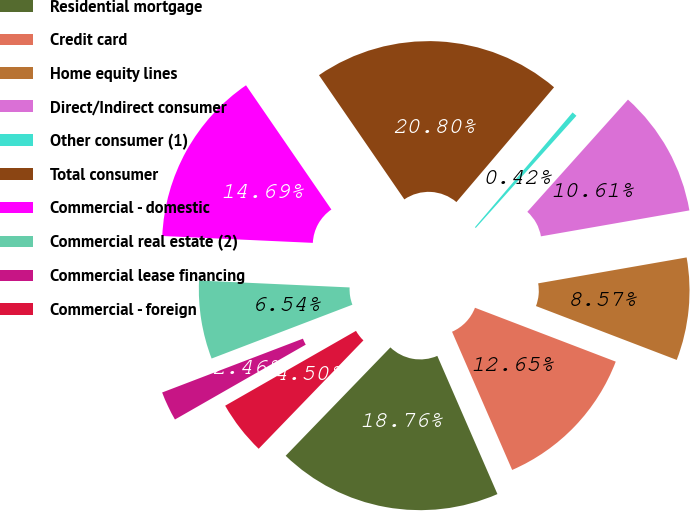<chart> <loc_0><loc_0><loc_500><loc_500><pie_chart><fcel>Residential mortgage<fcel>Credit card<fcel>Home equity lines<fcel>Direct/Indirect consumer<fcel>Other consumer (1)<fcel>Total consumer<fcel>Commercial - domestic<fcel>Commercial real estate (2)<fcel>Commercial lease financing<fcel>Commercial - foreign<nl><fcel>18.76%<fcel>12.65%<fcel>8.57%<fcel>10.61%<fcel>0.42%<fcel>20.8%<fcel>14.69%<fcel>6.54%<fcel>2.46%<fcel>4.5%<nl></chart> 